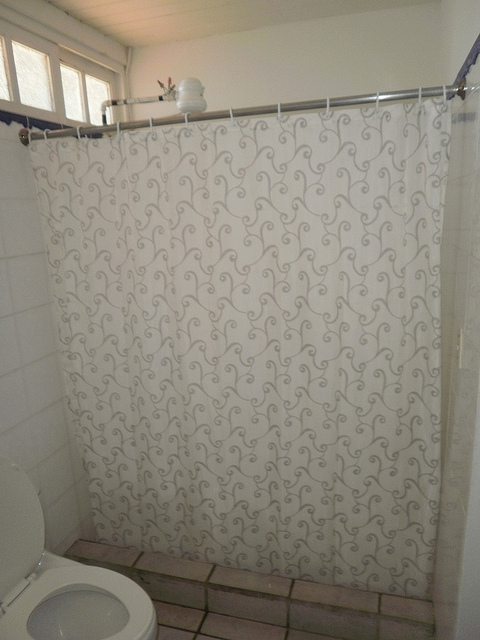<image>What type of basin is behind the curtain? It is unknown what type of basin is behind the curtain. It can be a shower or a bathtub. What type of basin is behind the curtain? I don't know what type of basin is behind the curtain. It can be shower, bathtub or water closet. 